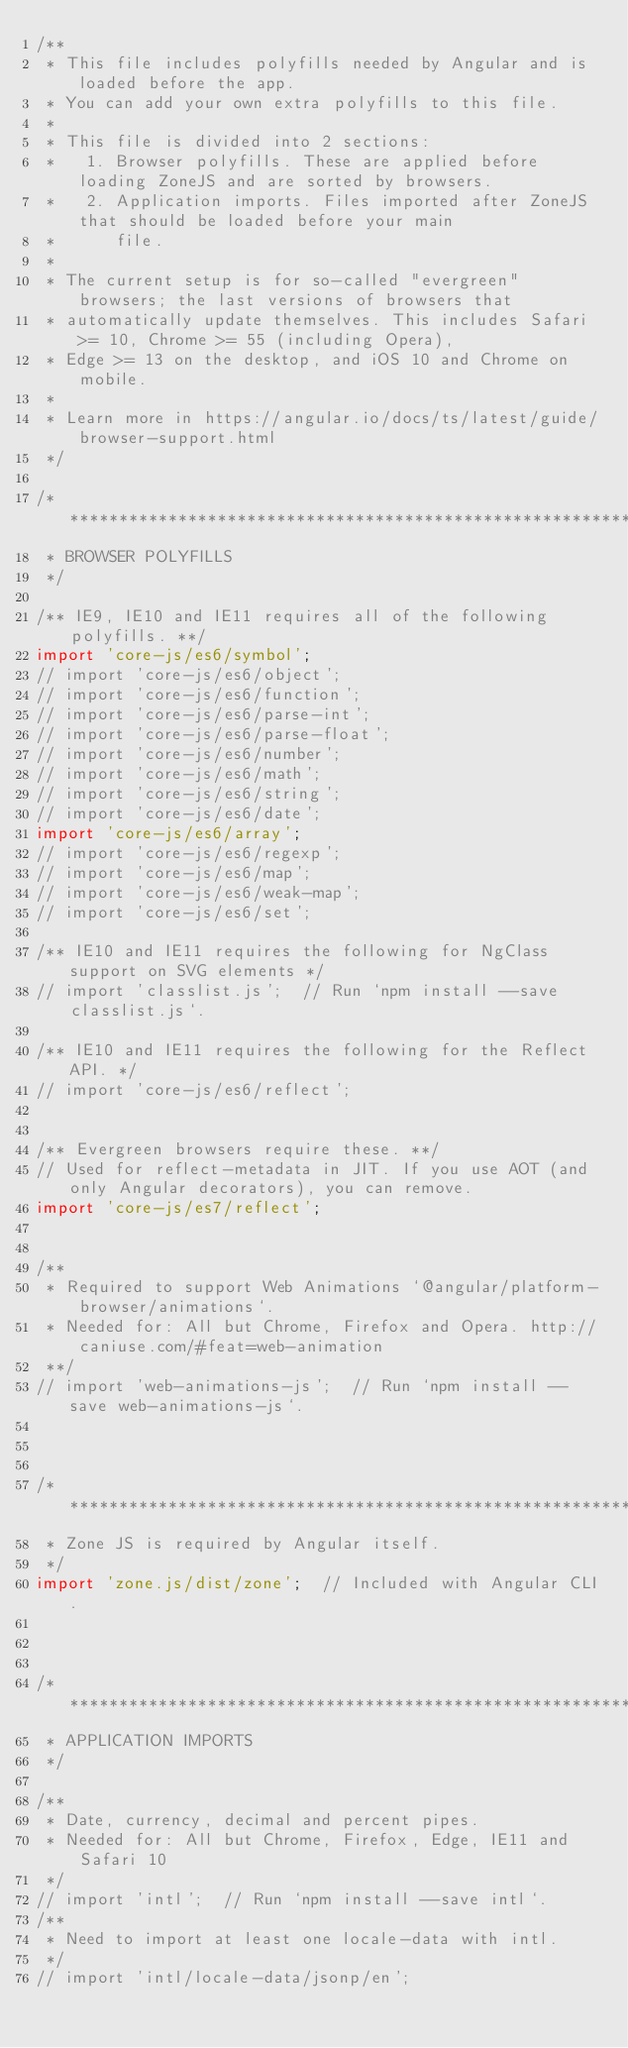Convert code to text. <code><loc_0><loc_0><loc_500><loc_500><_TypeScript_>/**
 * This file includes polyfills needed by Angular and is loaded before the app.
 * You can add your own extra polyfills to this file.
 *
 * This file is divided into 2 sections:
 *   1. Browser polyfills. These are applied before loading ZoneJS and are sorted by browsers.
 *   2. Application imports. Files imported after ZoneJS that should be loaded before your main
 *      file.
 *
 * The current setup is for so-called "evergreen" browsers; the last versions of browsers that
 * automatically update themselves. This includes Safari >= 10, Chrome >= 55 (including Opera),
 * Edge >= 13 on the desktop, and iOS 10 and Chrome on mobile.
 *
 * Learn more in https://angular.io/docs/ts/latest/guide/browser-support.html
 */

/***************************************************************************************************
 * BROWSER POLYFILLS
 */

/** IE9, IE10 and IE11 requires all of the following polyfills. **/
import 'core-js/es6/symbol';
// import 'core-js/es6/object';
// import 'core-js/es6/function';
// import 'core-js/es6/parse-int';
// import 'core-js/es6/parse-float';
// import 'core-js/es6/number';
// import 'core-js/es6/math';
// import 'core-js/es6/string';
// import 'core-js/es6/date';
import 'core-js/es6/array';
// import 'core-js/es6/regexp';
// import 'core-js/es6/map';
// import 'core-js/es6/weak-map';
// import 'core-js/es6/set';

/** IE10 and IE11 requires the following for NgClass support on SVG elements */
// import 'classlist.js';  // Run `npm install --save classlist.js`.

/** IE10 and IE11 requires the following for the Reflect API. */
// import 'core-js/es6/reflect';


/** Evergreen browsers require these. **/
// Used for reflect-metadata in JIT. If you use AOT (and only Angular decorators), you can remove.
import 'core-js/es7/reflect';


/**
 * Required to support Web Animations `@angular/platform-browser/animations`.
 * Needed for: All but Chrome, Firefox and Opera. http://caniuse.com/#feat=web-animation
 **/
// import 'web-animations-js';  // Run `npm install --save web-animations-js`.



/***************************************************************************************************
 * Zone JS is required by Angular itself.
 */
import 'zone.js/dist/zone';  // Included with Angular CLI.



/***************************************************************************************************
 * APPLICATION IMPORTS
 */

/**
 * Date, currency, decimal and percent pipes.
 * Needed for: All but Chrome, Firefox, Edge, IE11 and Safari 10
 */
// import 'intl';  // Run `npm install --save intl`.
/**
 * Need to import at least one locale-data with intl.
 */
// import 'intl/locale-data/jsonp/en';
</code> 